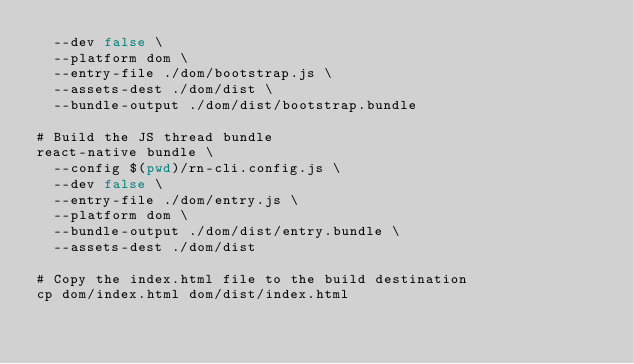<code> <loc_0><loc_0><loc_500><loc_500><_Bash_>  --dev false \
  --platform dom \
  --entry-file ./dom/bootstrap.js \
  --assets-dest ./dom/dist \
  --bundle-output ./dom/dist/bootstrap.bundle

# Build the JS thread bundle
react-native bundle \
  --config $(pwd)/rn-cli.config.js \
  --dev false \
  --entry-file ./dom/entry.js \
  --platform dom \
  --bundle-output ./dom/dist/entry.bundle \
  --assets-dest ./dom/dist

# Copy the index.html file to the build destination
cp dom/index.html dom/dist/index.html
</code> 